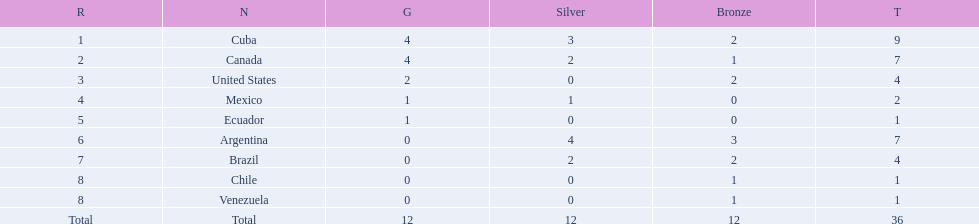What is the total number of nations that did not win gold? 4. 